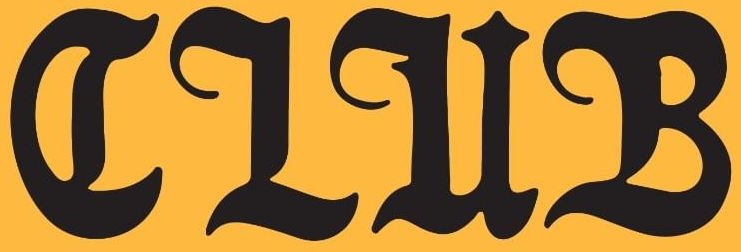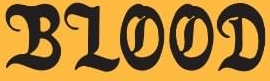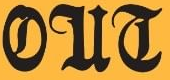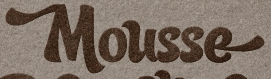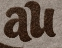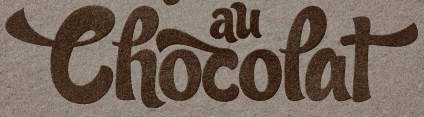Read the text from these images in sequence, separated by a semicolon. CLUB; BLOOD; OUT; Mousse; au; Thocopat 